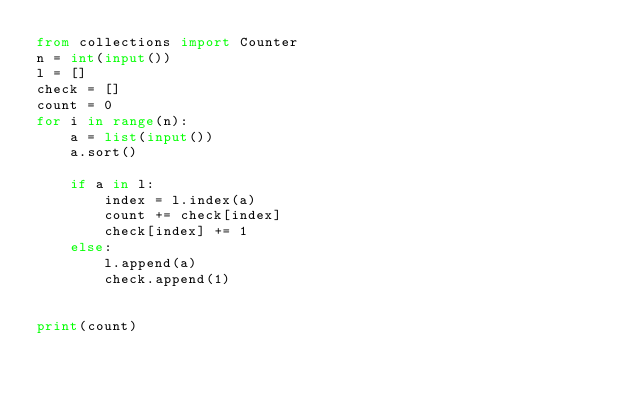Convert code to text. <code><loc_0><loc_0><loc_500><loc_500><_Python_>from collections import Counter
n = int(input())
l = []
check = []
count = 0
for i in range(n):
    a = list(input())
    a.sort()
    
    if a in l:
        index = l.index(a)
        count += check[index]
        check[index] += 1
    else:
        l.append(a)
        check.append(1)


print(count)</code> 